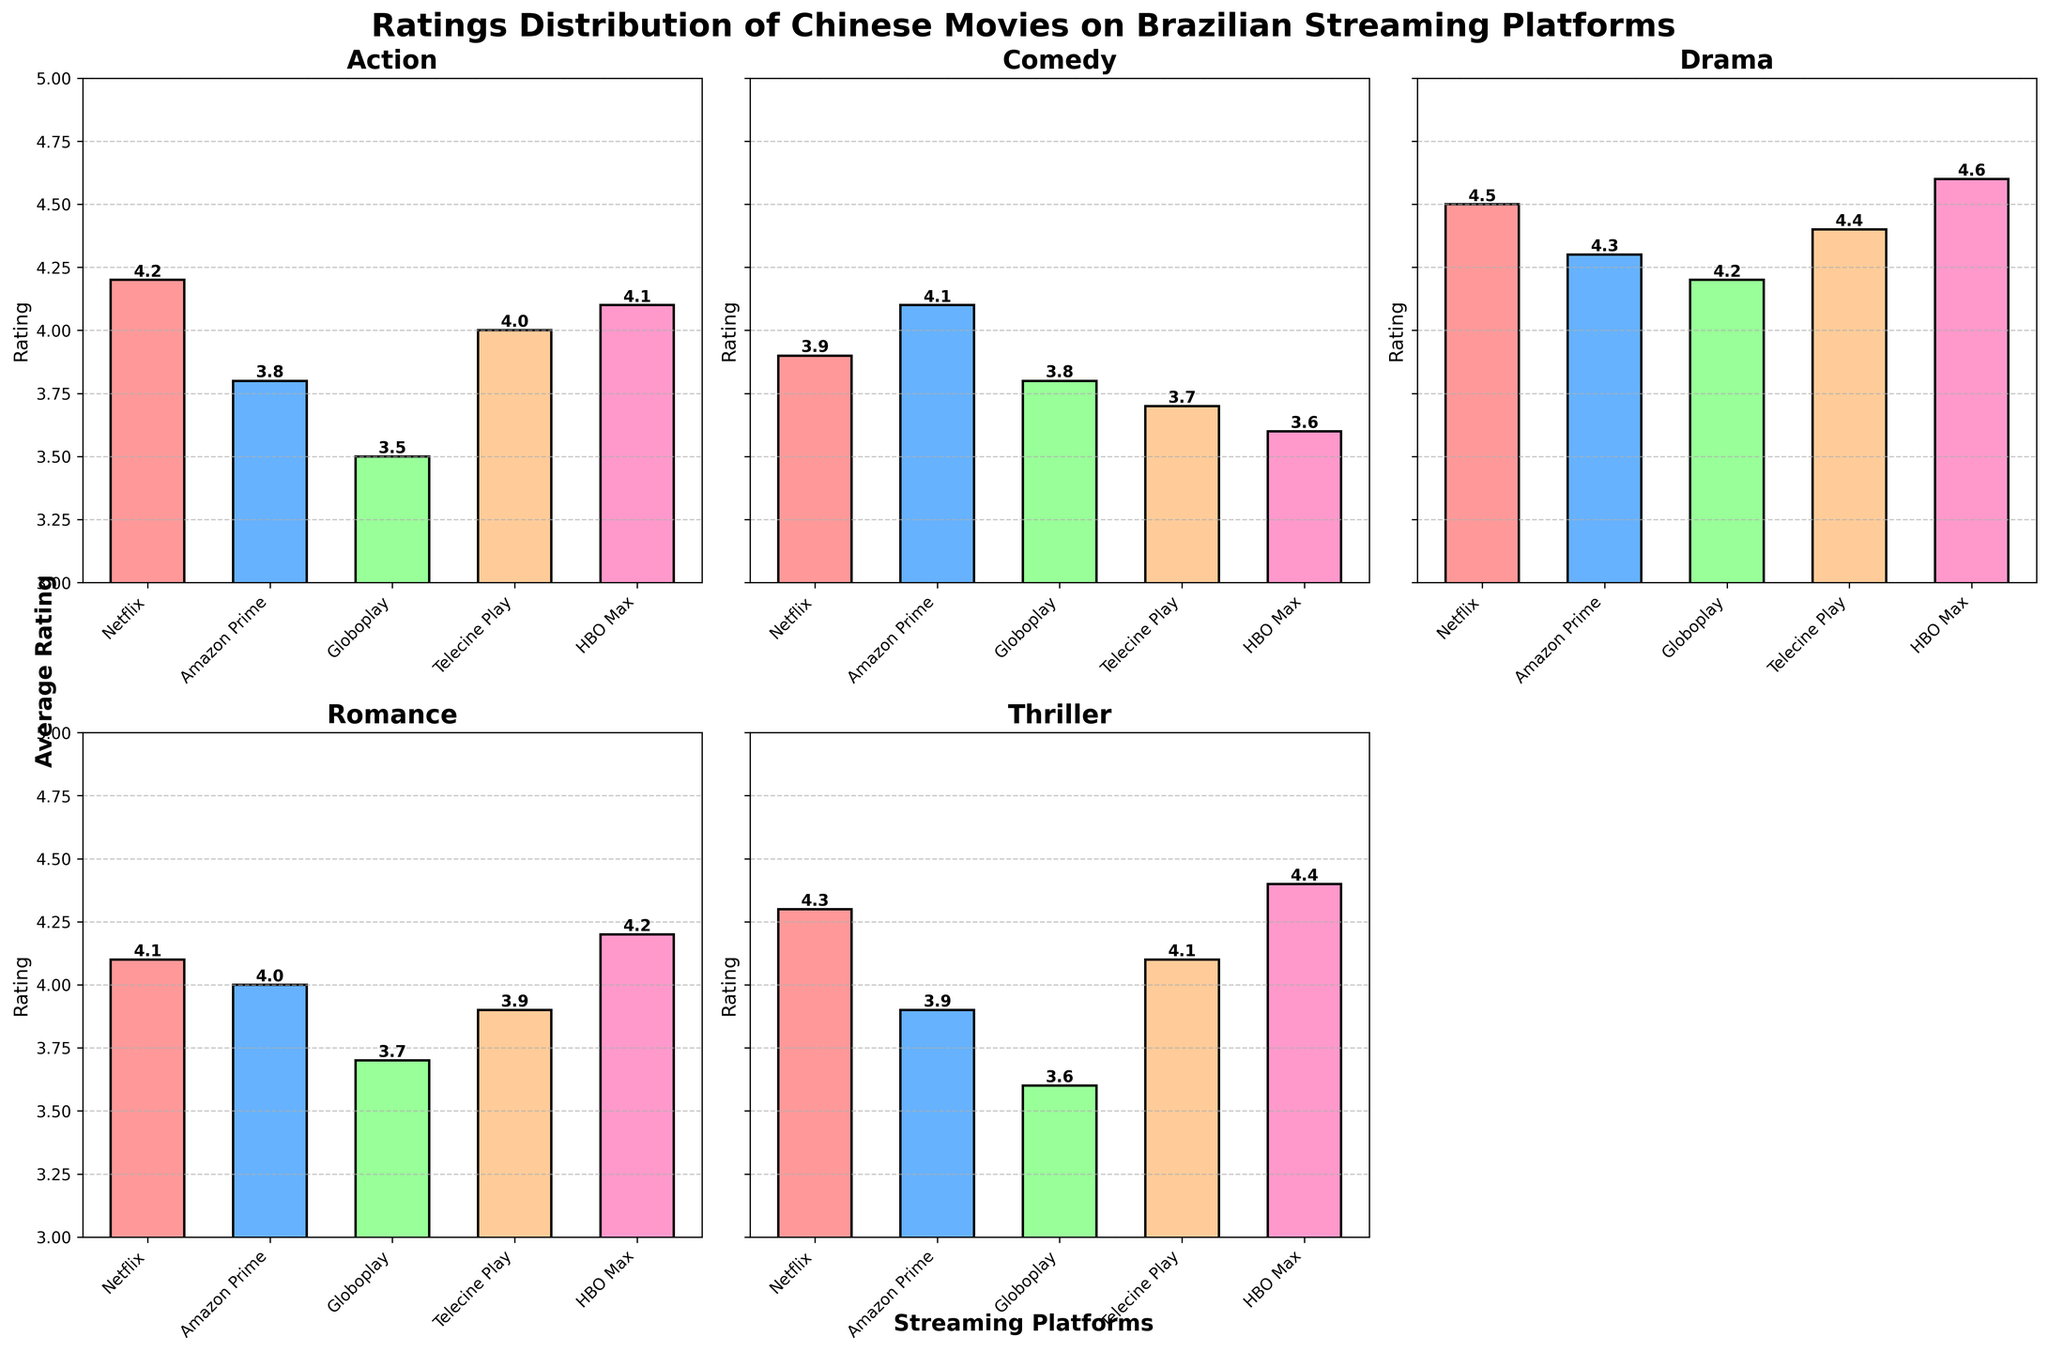What is the highest average rating for Action movies? Check the ratings for Action movies across all streaming platforms and identify the highest value.
Answer: HBO Max (4.1) Which genre has the highest shared rating between Netflix and Amazon Prime? Compare the ratings for Netflix and Amazon Prime across all genres and find the genre with matching highest rating.
Answer: Drama (4.3) Which platform has the most consistent ratings across all genres? Examine the ratings variation across genres for each platform and identify the one with the smallest range.
Answer: HBO Max (3.6 - 4.6) Between Netflix and HBO Max, which platform has a higher average rating for Romance movies? Compare the Romance movies' ratings between Netflix and HBO Max.
Answer: HBO Max (4.2) Which genre appears to have the most variable ratings between streaming platforms? Look for the genre with the largest difference between the highest and lowest ratings across all platforms.
Answer: Action (3.5 - 4.2) Rank the platforms from highest to lowest average rating for Drama movies. List the Drama ratings for all platforms and rank them in descending order.
Answer: HBO Max (4.6), Netflix (4.5), Telecine Play (4.4), Amazon Prime (4.3), Globoplay (4.2) What is the average rating for Comedy movies on all platforms combined? Sum the Comedy ratings across all platforms and divide by the number of platforms.
Answer: 3.82 Identify the platform with the lowest rating for Thriller movies. Find the Thriller rating for each platform and identify the lowest one.
Answer: Globoplay (3.6) Which platform has the lowest average rating for all genres combined? Calculate the average rating across all genres for each platform and identify the lowest.
Answer: Globoplay (3.76) Between Netflix and Amazon Prime, which platform has better overall ratings for Chinese movies? Compare the average ratings across all genres between Netflix and Amazon Prime.
Answer: Netflix 